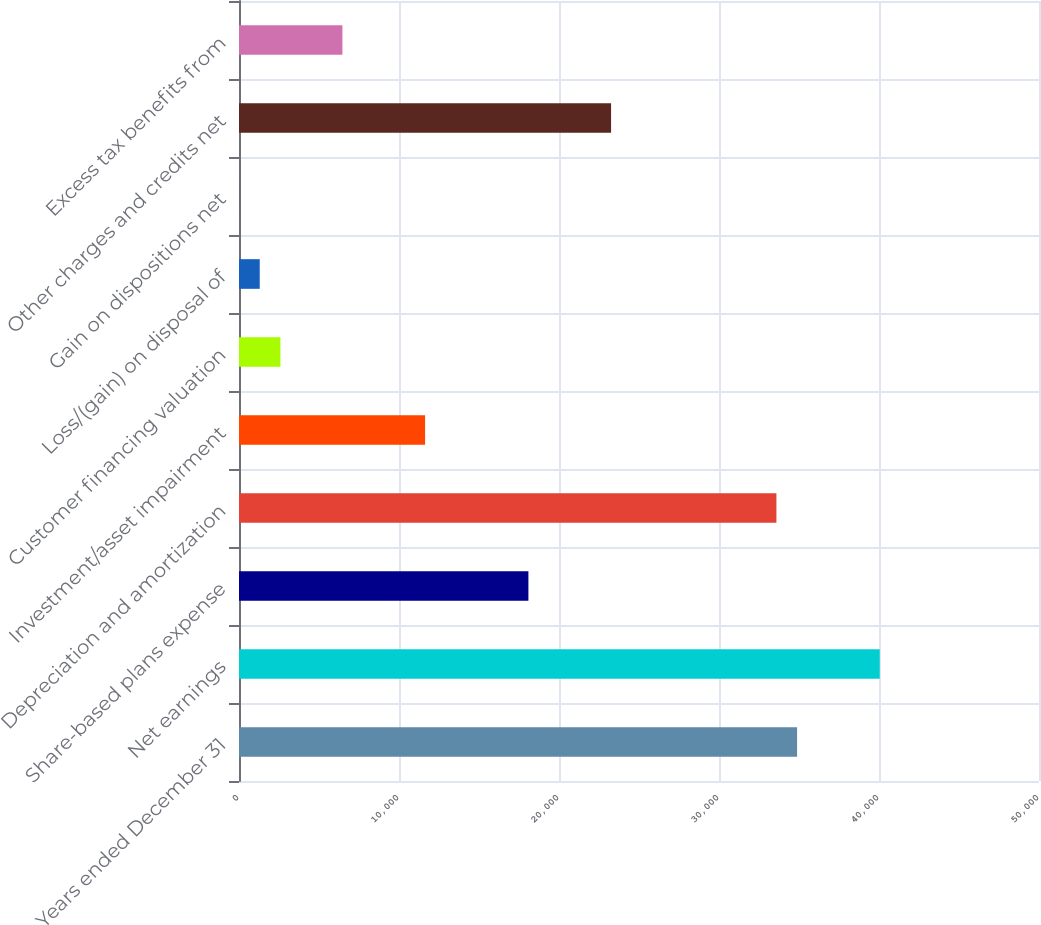Convert chart to OTSL. <chart><loc_0><loc_0><loc_500><loc_500><bar_chart><fcel>Years ended December 31<fcel>Net earnings<fcel>Share-based plans expense<fcel>Depreciation and amortization<fcel>Investment/asset impairment<fcel>Customer financing valuation<fcel>Loss/(gain) on disposal of<fcel>Gain on dispositions net<fcel>Other charges and credits net<fcel>Excess tax benefits from<nl><fcel>34879.9<fcel>40046.7<fcel>18087.8<fcel>33588.2<fcel>11629.3<fcel>2587.4<fcel>1295.7<fcel>4<fcel>23254.6<fcel>6462.5<nl></chart> 